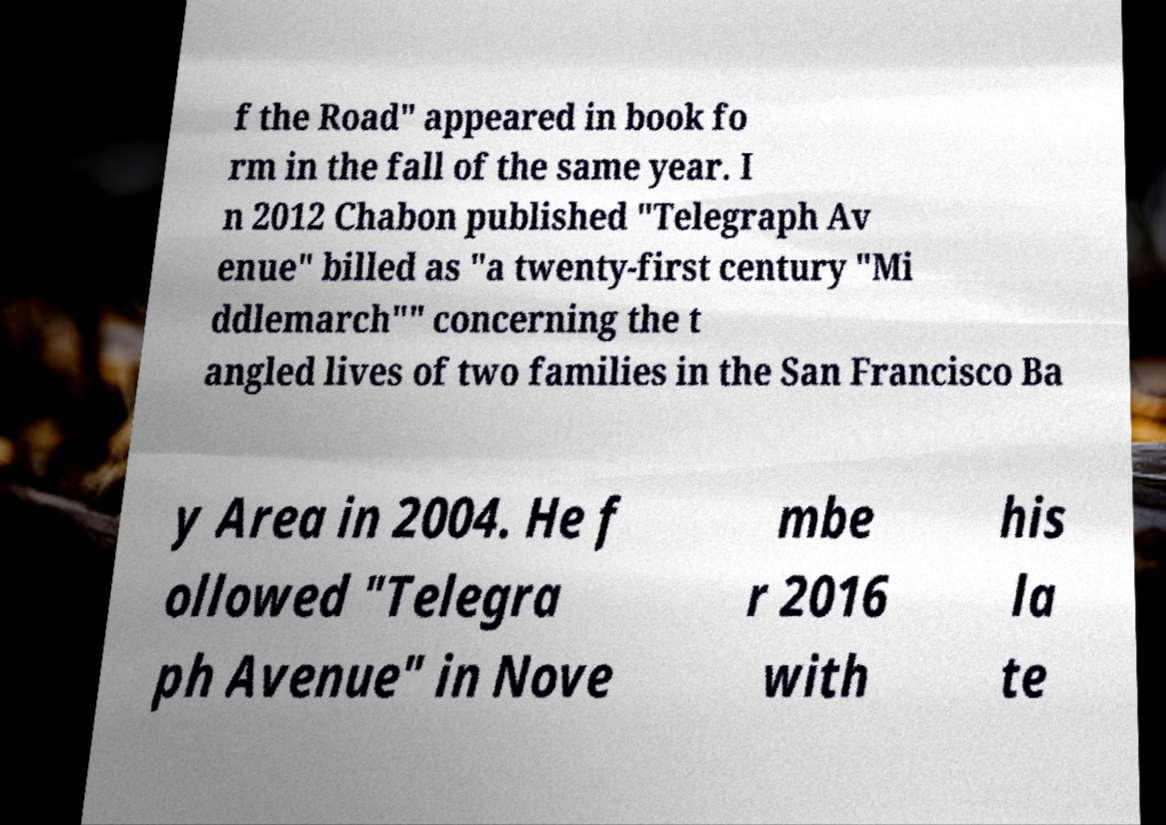Could you extract and type out the text from this image? f the Road" appeared in book fo rm in the fall of the same year. I n 2012 Chabon published "Telegraph Av enue" billed as "a twenty-first century "Mi ddlemarch"" concerning the t angled lives of two families in the San Francisco Ba y Area in 2004. He f ollowed "Telegra ph Avenue" in Nove mbe r 2016 with his la te 